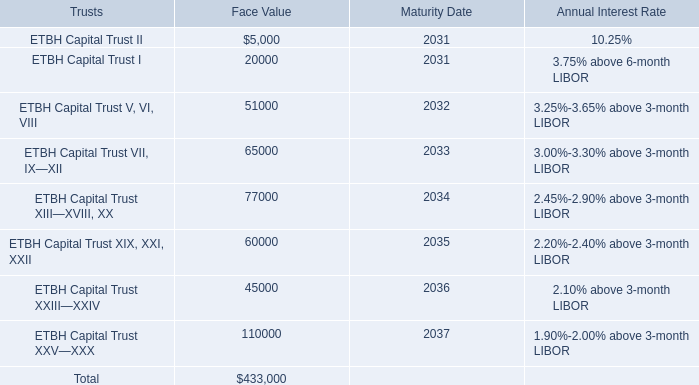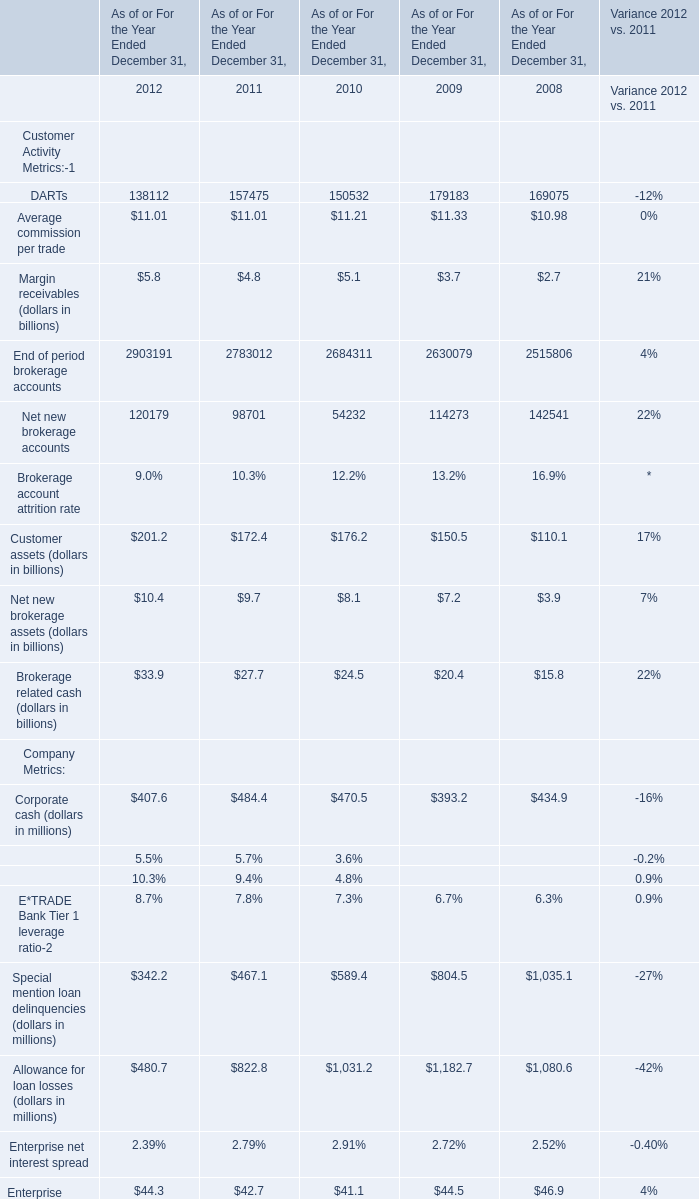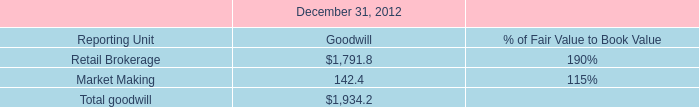What is the average amount of Retail Brokerage of December 31, 2012 Goodwill, and ETBH Capital Trust I of Maturity Date ? 
Computations: ((1791.8 + 2031.0) / 2)
Answer: 1911.4. 